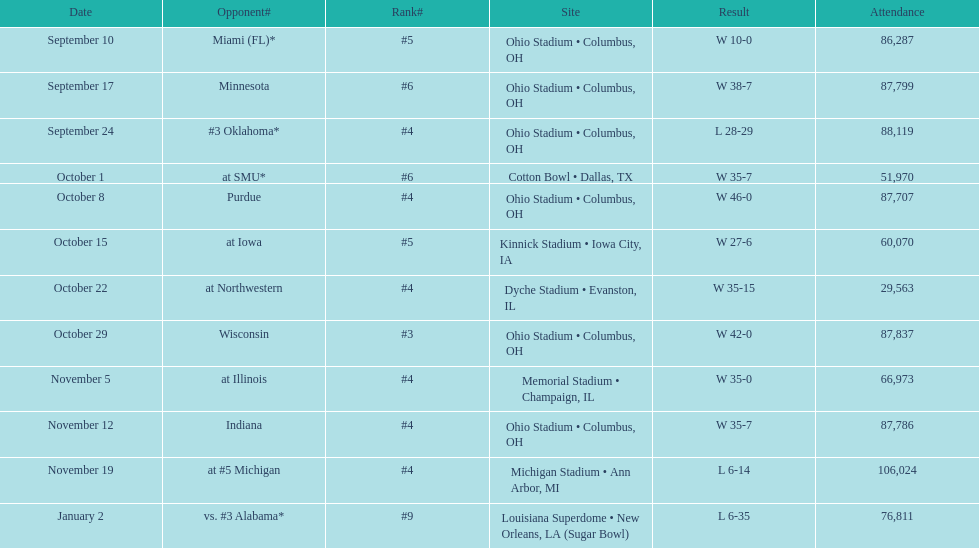Which date was attended by the most people? November 19. 